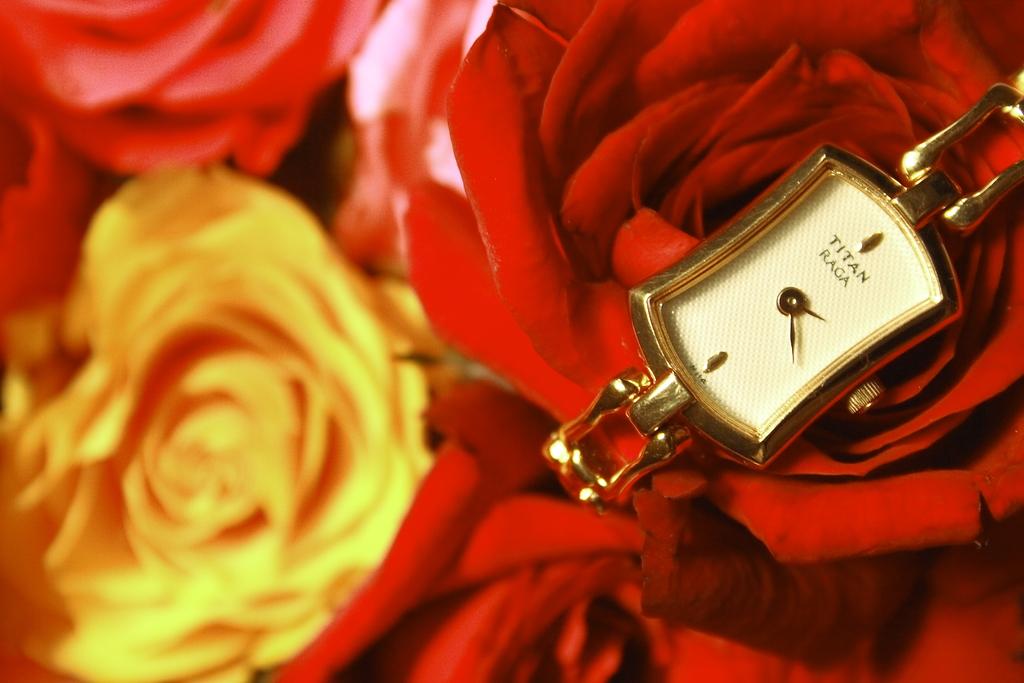What is this watch called?
Provide a succinct answer. Titan raga. What time is the display?
Offer a very short reply. 2:20. 